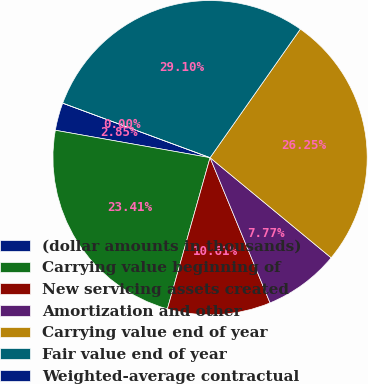Convert chart to OTSL. <chart><loc_0><loc_0><loc_500><loc_500><pie_chart><fcel>(dollar amounts in thousands)<fcel>Carrying value beginning of<fcel>New servicing assets created<fcel>Amortization and other<fcel>Carrying value end of year<fcel>Fair value end of year<fcel>Weighted-average contractual<nl><fcel>2.85%<fcel>23.41%<fcel>10.61%<fcel>7.77%<fcel>26.25%<fcel>29.1%<fcel>0.0%<nl></chart> 